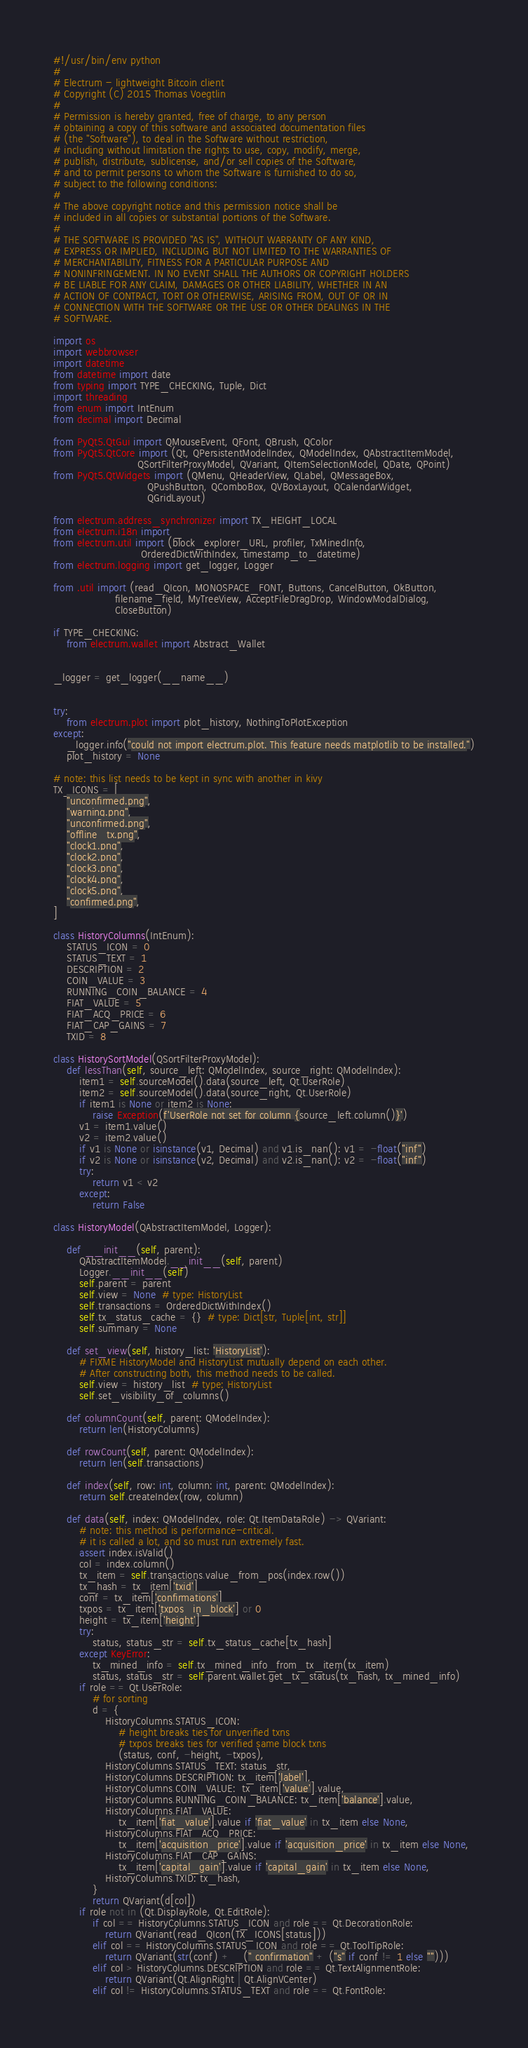Convert code to text. <code><loc_0><loc_0><loc_500><loc_500><_Python_>#!/usr/bin/env python
#
# Electrum - lightweight Bitcoin client
# Copyright (C) 2015 Thomas Voegtlin
#
# Permission is hereby granted, free of charge, to any person
# obtaining a copy of this software and associated documentation files
# (the "Software"), to deal in the Software without restriction,
# including without limitation the rights to use, copy, modify, merge,
# publish, distribute, sublicense, and/or sell copies of the Software,
# and to permit persons to whom the Software is furnished to do so,
# subject to the following conditions:
#
# The above copyright notice and this permission notice shall be
# included in all copies or substantial portions of the Software.
#
# THE SOFTWARE IS PROVIDED "AS IS", WITHOUT WARRANTY OF ANY KIND,
# EXPRESS OR IMPLIED, INCLUDING BUT NOT LIMITED TO THE WARRANTIES OF
# MERCHANTABILITY, FITNESS FOR A PARTICULAR PURPOSE AND
# NONINFRINGEMENT. IN NO EVENT SHALL THE AUTHORS OR COPYRIGHT HOLDERS
# BE LIABLE FOR ANY CLAIM, DAMAGES OR OTHER LIABILITY, WHETHER IN AN
# ACTION OF CONTRACT, TORT OR OTHERWISE, ARISING FROM, OUT OF OR IN
# CONNECTION WITH THE SOFTWARE OR THE USE OR OTHER DEALINGS IN THE
# SOFTWARE.

import os
import webbrowser
import datetime
from datetime import date
from typing import TYPE_CHECKING, Tuple, Dict
import threading
from enum import IntEnum
from decimal import Decimal

from PyQt5.QtGui import QMouseEvent, QFont, QBrush, QColor
from PyQt5.QtCore import (Qt, QPersistentModelIndex, QModelIndex, QAbstractItemModel,
                          QSortFilterProxyModel, QVariant, QItemSelectionModel, QDate, QPoint)
from PyQt5.QtWidgets import (QMenu, QHeaderView, QLabel, QMessageBox,
                             QPushButton, QComboBox, QVBoxLayout, QCalendarWidget,
                             QGridLayout)

from electrum.address_synchronizer import TX_HEIGHT_LOCAL
from electrum.i18n import _
from electrum.util import (block_explorer_URL, profiler, TxMinedInfo,
                           OrderedDictWithIndex, timestamp_to_datetime)
from electrum.logging import get_logger, Logger

from .util import (read_QIcon, MONOSPACE_FONT, Buttons, CancelButton, OkButton,
                   filename_field, MyTreeView, AcceptFileDragDrop, WindowModalDialog,
                   CloseButton)

if TYPE_CHECKING:
    from electrum.wallet import Abstract_Wallet


_logger = get_logger(__name__)


try:
    from electrum.plot import plot_history, NothingToPlotException
except:
    _logger.info("could not import electrum.plot. This feature needs matplotlib to be installed.")
    plot_history = None

# note: this list needs to be kept in sync with another in kivy
TX_ICONS = [
    "unconfirmed.png",
    "warning.png",
    "unconfirmed.png",
    "offline_tx.png",
    "clock1.png",
    "clock2.png",
    "clock3.png",
    "clock4.png",
    "clock5.png",
    "confirmed.png",
]

class HistoryColumns(IntEnum):
    STATUS_ICON = 0
    STATUS_TEXT = 1
    DESCRIPTION = 2
    COIN_VALUE = 3
    RUNNING_COIN_BALANCE = 4
    FIAT_VALUE = 5
    FIAT_ACQ_PRICE = 6
    FIAT_CAP_GAINS = 7
    TXID = 8

class HistorySortModel(QSortFilterProxyModel):
    def lessThan(self, source_left: QModelIndex, source_right: QModelIndex):
        item1 = self.sourceModel().data(source_left, Qt.UserRole)
        item2 = self.sourceModel().data(source_right, Qt.UserRole)
        if item1 is None or item2 is None:
            raise Exception(f'UserRole not set for column {source_left.column()}')
        v1 = item1.value()
        v2 = item2.value()
        if v1 is None or isinstance(v1, Decimal) and v1.is_nan(): v1 = -float("inf")
        if v2 is None or isinstance(v2, Decimal) and v2.is_nan(): v2 = -float("inf")
        try:
            return v1 < v2
        except:
            return False

class HistoryModel(QAbstractItemModel, Logger):

    def __init__(self, parent):
        QAbstractItemModel.__init__(self, parent)
        Logger.__init__(self)
        self.parent = parent
        self.view = None  # type: HistoryList
        self.transactions = OrderedDictWithIndex()
        self.tx_status_cache = {}  # type: Dict[str, Tuple[int, str]]
        self.summary = None

    def set_view(self, history_list: 'HistoryList'):
        # FIXME HistoryModel and HistoryList mutually depend on each other.
        # After constructing both, this method needs to be called.
        self.view = history_list  # type: HistoryList
        self.set_visibility_of_columns()

    def columnCount(self, parent: QModelIndex):
        return len(HistoryColumns)

    def rowCount(self, parent: QModelIndex):
        return len(self.transactions)

    def index(self, row: int, column: int, parent: QModelIndex):
        return self.createIndex(row, column)

    def data(self, index: QModelIndex, role: Qt.ItemDataRole) -> QVariant:
        # note: this method is performance-critical.
        # it is called a lot, and so must run extremely fast.
        assert index.isValid()
        col = index.column()
        tx_item = self.transactions.value_from_pos(index.row())
        tx_hash = tx_item['txid']
        conf = tx_item['confirmations']
        txpos = tx_item['txpos_in_block'] or 0
        height = tx_item['height']
        try:
            status, status_str = self.tx_status_cache[tx_hash]
        except KeyError:
            tx_mined_info = self.tx_mined_info_from_tx_item(tx_item)
            status, status_str = self.parent.wallet.get_tx_status(tx_hash, tx_mined_info)
        if role == Qt.UserRole:
            # for sorting
            d = {
                HistoryColumns.STATUS_ICON:
                    # height breaks ties for unverified txns
                    # txpos breaks ties for verified same block txns
                    (status, conf, -height, -txpos),
                HistoryColumns.STATUS_TEXT: status_str,
                HistoryColumns.DESCRIPTION: tx_item['label'],
                HistoryColumns.COIN_VALUE:  tx_item['value'].value,
                HistoryColumns.RUNNING_COIN_BALANCE: tx_item['balance'].value,
                HistoryColumns.FIAT_VALUE:
                    tx_item['fiat_value'].value if 'fiat_value' in tx_item else None,
                HistoryColumns.FIAT_ACQ_PRICE:
                    tx_item['acquisition_price'].value if 'acquisition_price' in tx_item else None,
                HistoryColumns.FIAT_CAP_GAINS:
                    tx_item['capital_gain'].value if 'capital_gain' in tx_item else None,
                HistoryColumns.TXID: tx_hash,
            }
            return QVariant(d[col])
        if role not in (Qt.DisplayRole, Qt.EditRole):
            if col == HistoryColumns.STATUS_ICON and role == Qt.DecorationRole:
                return QVariant(read_QIcon(TX_ICONS[status]))
            elif col == HistoryColumns.STATUS_ICON and role == Qt.ToolTipRole:
                return QVariant(str(conf) + _(" confirmation" + ("s" if conf != 1 else "")))
            elif col > HistoryColumns.DESCRIPTION and role == Qt.TextAlignmentRole:
                return QVariant(Qt.AlignRight | Qt.AlignVCenter)
            elif col != HistoryColumns.STATUS_TEXT and role == Qt.FontRole:</code> 